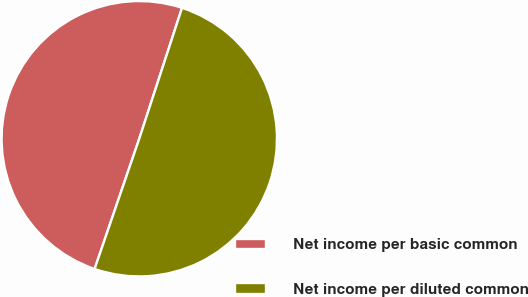<chart> <loc_0><loc_0><loc_500><loc_500><pie_chart><fcel>Net income per basic common<fcel>Net income per diluted common<nl><fcel>49.77%<fcel>50.23%<nl></chart> 